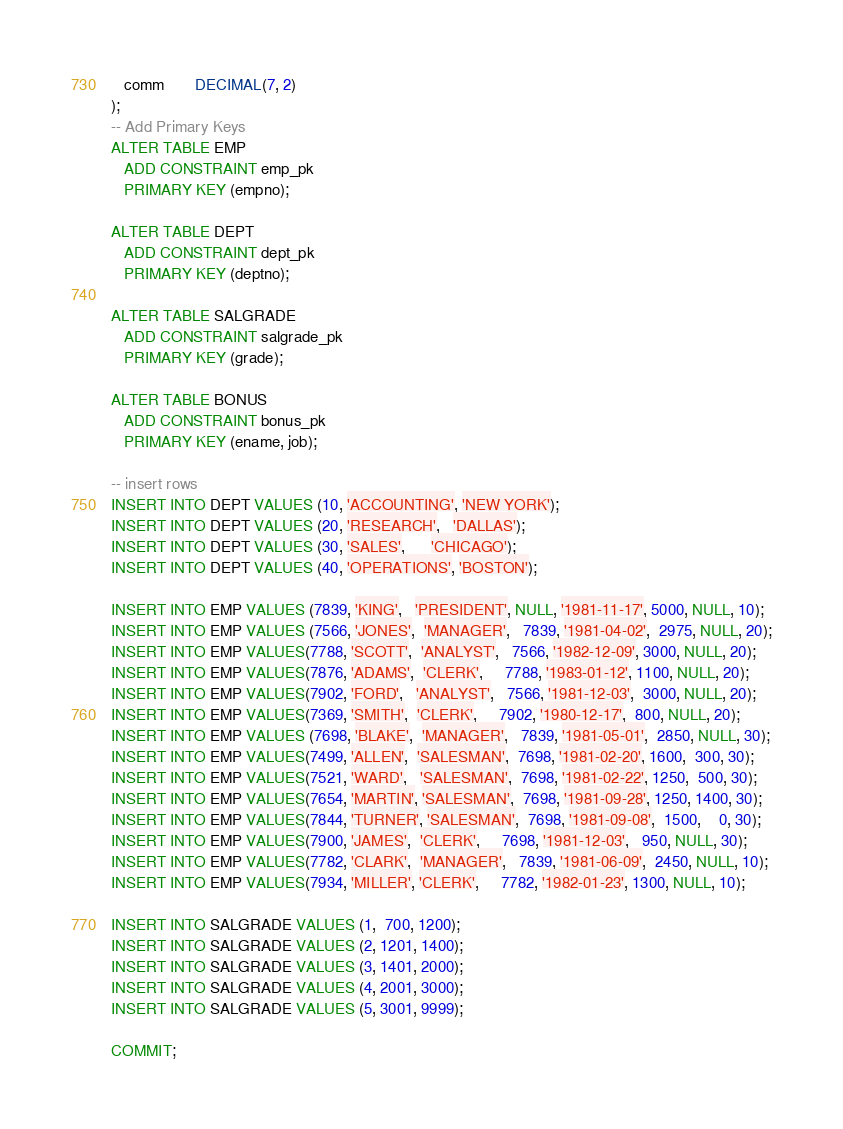Convert code to text. <code><loc_0><loc_0><loc_500><loc_500><_SQL_>   comm       DECIMAL(7, 2)
);
-- Add Primary Keys
ALTER TABLE EMP
   ADD CONSTRAINT emp_pk
   PRIMARY KEY (empno);

ALTER TABLE DEPT
   ADD CONSTRAINT dept_pk
   PRIMARY KEY (deptno);

ALTER TABLE SALGRADE
   ADD CONSTRAINT salgrade_pk
   PRIMARY KEY (grade);

ALTER TABLE BONUS
   ADD CONSTRAINT bonus_pk
   PRIMARY KEY (ename, job);

-- insert rows
INSERT INTO DEPT VALUES (10, 'ACCOUNTING', 'NEW YORK');
INSERT INTO DEPT VALUES (20, 'RESEARCH',   'DALLAS');
INSERT INTO DEPT VALUES (30, 'SALES',      'CHICAGO');
INSERT INTO DEPT VALUES (40, 'OPERATIONS', 'BOSTON');
 
INSERT INTO EMP VALUES (7839, 'KING',   'PRESIDENT', NULL, '1981-11-17', 5000, NULL, 10);
INSERT INTO EMP VALUES (7566, 'JONES',  'MANAGER',   7839, '1981-04-02',  2975, NULL, 20);
INSERT INTO EMP VALUES(7788, 'SCOTT',  'ANALYST',   7566, '1982-12-09', 3000, NULL, 20);
INSERT INTO EMP VALUES(7876, 'ADAMS',  'CLERK',     7788, '1983-01-12', 1100, NULL, 20);
INSERT INTO EMP VALUES(7902, 'FORD',   'ANALYST',   7566, '1981-12-03',  3000, NULL, 20);
INSERT INTO EMP VALUES(7369, 'SMITH',  'CLERK',     7902, '1980-12-17',  800, NULL, 20);
INSERT INTO EMP VALUES (7698, 'BLAKE',  'MANAGER',   7839, '1981-05-01',  2850, NULL, 30);
INSERT INTO EMP VALUES(7499, 'ALLEN',  'SALESMAN',  7698, '1981-02-20', 1600,  300, 30);
INSERT INTO EMP VALUES(7521, 'WARD',   'SALESMAN',  7698, '1981-02-22', 1250,  500, 30);
INSERT INTO EMP VALUES(7654, 'MARTIN', 'SALESMAN',  7698, '1981-09-28', 1250, 1400, 30);
INSERT INTO EMP VALUES(7844, 'TURNER', 'SALESMAN',  7698, '1981-09-08',  1500,    0, 30);
INSERT INTO EMP VALUES(7900, 'JAMES',  'CLERK',     7698, '1981-12-03',   950, NULL, 30);
INSERT INTO EMP VALUES(7782, 'CLARK',  'MANAGER',   7839, '1981-06-09',  2450, NULL, 10);
INSERT INTO EMP VALUES(7934, 'MILLER', 'CLERK',     7782, '1982-01-23', 1300, NULL, 10);
 
INSERT INTO SALGRADE VALUES (1,  700, 1200);
INSERT INTO SALGRADE VALUES (2, 1201, 1400);
INSERT INTO SALGRADE VALUES (3, 1401, 2000);
INSERT INTO SALGRADE VALUES (4, 2001, 3000);
INSERT INTO SALGRADE VALUES (5, 3001, 9999);

COMMIT;</code> 